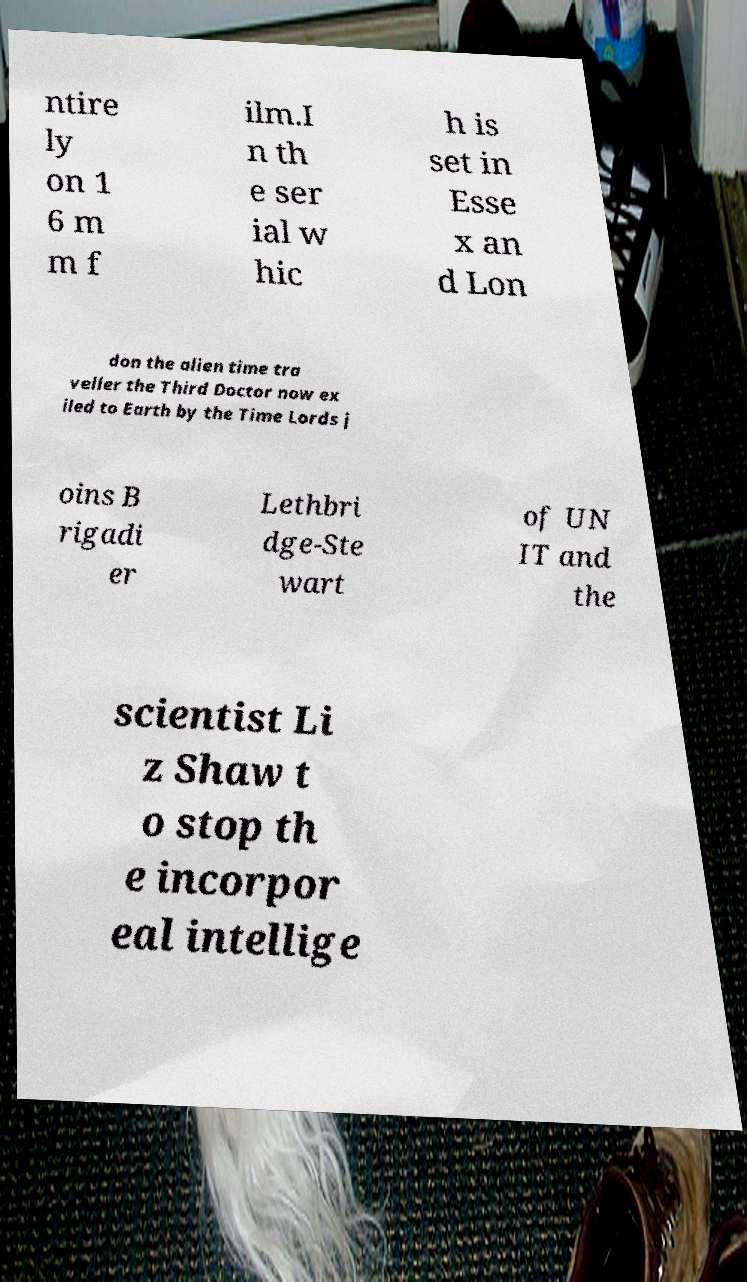Could you assist in decoding the text presented in this image and type it out clearly? ntire ly on 1 6 m m f ilm.I n th e ser ial w hic h is set in Esse x an d Lon don the alien time tra veller the Third Doctor now ex iled to Earth by the Time Lords j oins B rigadi er Lethbri dge-Ste wart of UN IT and the scientist Li z Shaw t o stop th e incorpor eal intellige 